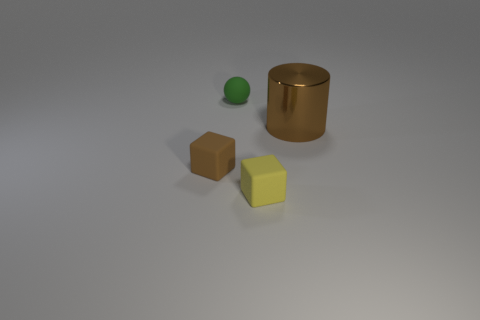Are there any other things that are made of the same material as the tiny brown cube?
Provide a short and direct response. Yes. What material is the tiny yellow thing?
Your response must be concise. Rubber. There is a small block that is left of the small rubber ball; what material is it?
Your answer should be compact. Rubber. Are there any other things of the same color as the large object?
Provide a succinct answer. Yes. What size is the brown thing that is made of the same material as the green object?
Your answer should be compact. Small. What number of small things are matte blocks or gray matte objects?
Ensure brevity in your answer.  2. There is a cube on the right side of the small object that is behind the brown thing on the left side of the cylinder; what is its size?
Offer a very short reply. Small. What number of rubber things have the same size as the shiny cylinder?
Keep it short and to the point. 0. How many objects are either brown cylinders or objects on the left side of the small green ball?
Your answer should be compact. 2. What shape is the large brown shiny thing?
Make the answer very short. Cylinder. 